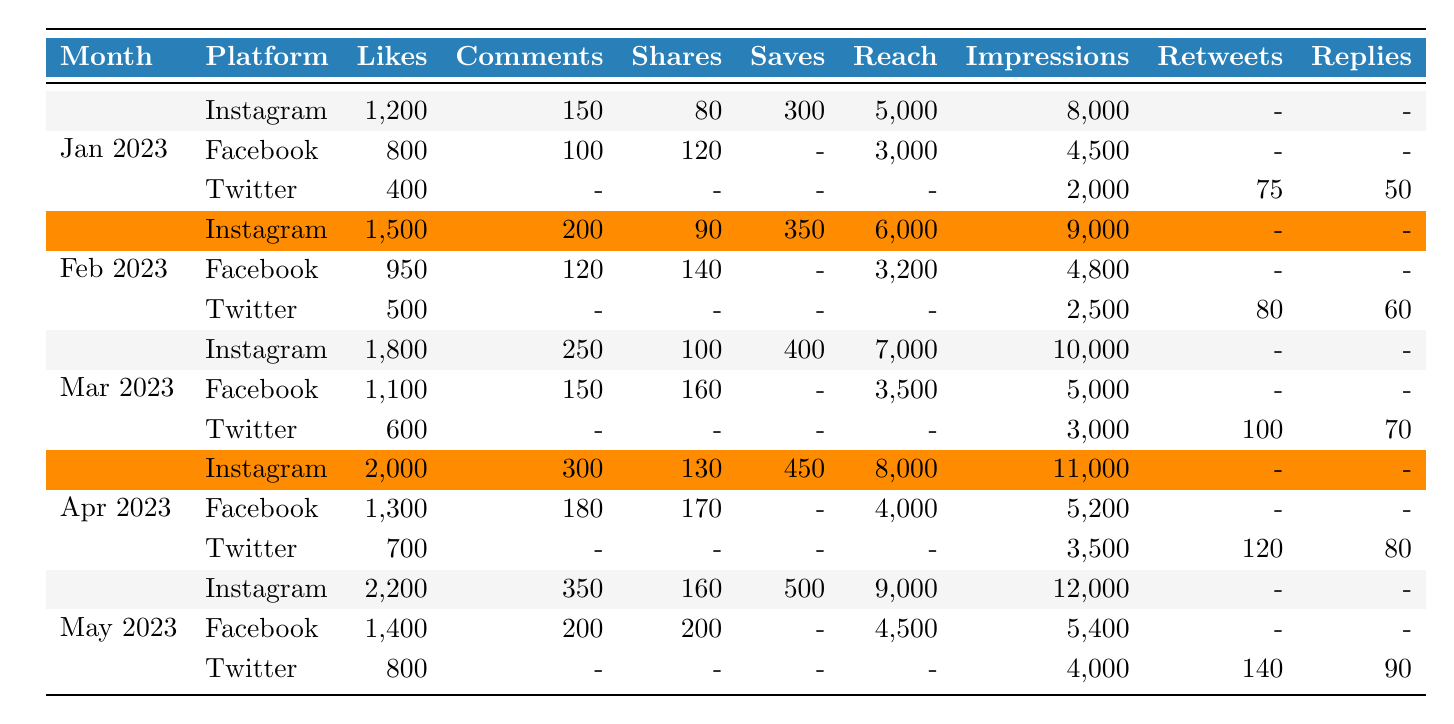What's the total number of likes on Instagram for January 2023? The table shows that for January 2023, Instagram received 1,200 likes.
Answer: 1,200 What platform had the highest number of likes in May 2023? In May 2023, Instagram had 2,200 likes, which is higher than Facebook's 1,400 and Twitter's 800.
Answer: Instagram How many comments were made on Facebook in February 2023? The table indicates that Facebook received 120 comments in February 2023.
Answer: 120 What is the average number of shares on Twitter across the months listed? The shares for Twitter are 0 in January, 0 in February, 0 in March, 0 in April, and 0 in May, so the average is (0 + 0 + 0 + 0 + 0)/5 = 0.
Answer: 0 Which month saw the highest reach on Instagram? The maximum reach for Instagram is noted in April 2023, with a reach of 8,000, compared to lower reach values in the other months.
Answer: April 2023 Did Facebook have more likes than Twitter in March 2023? Yes, Facebook had 1,100 likes, while Twitter had 600 likes in March 2023, so Facebook had more likes than Twitter.
Answer: Yes What is the difference in impressions between Instagram in April and Instagram in January? Instagram had 11,000 impressions in April and 8,000 impressions in January, so the difference is 11,000 - 8,000 = 3,000.
Answer: 3,000 How many total likes were received from all platforms in February 2023? Adding up the likes in February: Instagram (1,500) + Facebook (950) + Twitter (500) = 2,950.
Answer: 2,950 Which platform had the most saves in April 2023? In April 2023, Instagram had 450 saves, which is higher than the other platforms (which had 0).
Answer: Instagram What is the trend in the number of likes on Instagram from January to May 2023? The likes on Instagram increased from 1,200 in January, to 2,200 in May, indicating a positive trend.
Answer: Increasing trend 